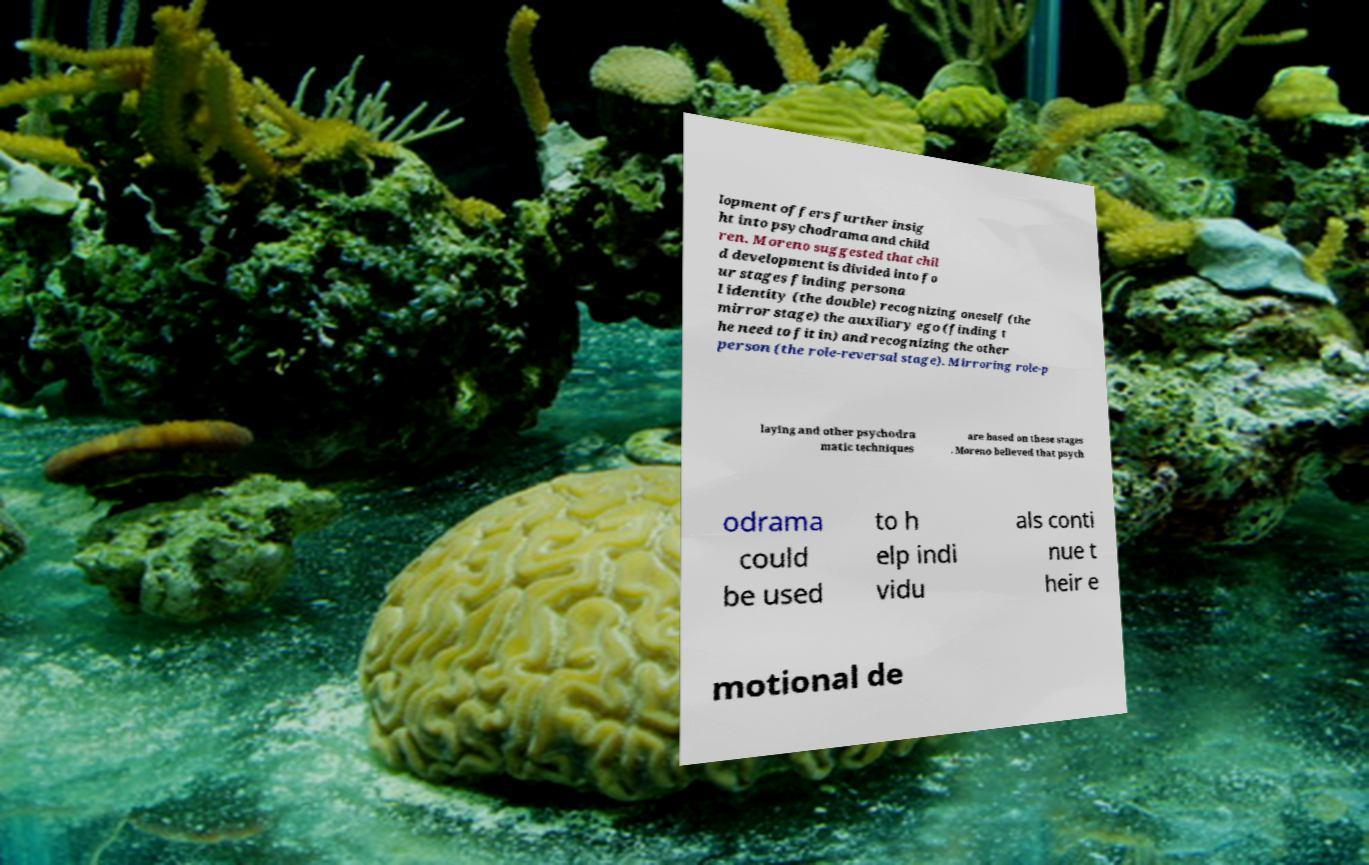I need the written content from this picture converted into text. Can you do that? lopment offers further insig ht into psychodrama and child ren. Moreno suggested that chil d development is divided into fo ur stages finding persona l identity (the double) recognizing oneself (the mirror stage) the auxiliary ego (finding t he need to fit in) and recognizing the other person (the role-reversal stage). Mirroring role-p laying and other psychodra matic techniques are based on these stages . Moreno believed that psych odrama could be used to h elp indi vidu als conti nue t heir e motional de 